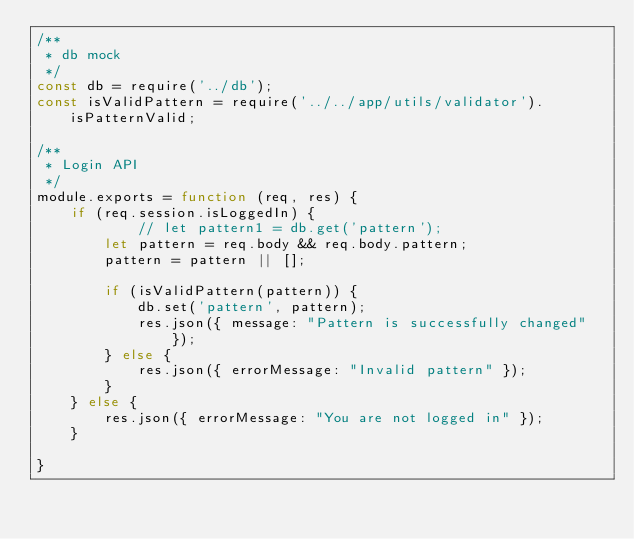Convert code to text. <code><loc_0><loc_0><loc_500><loc_500><_JavaScript_>/**
 * db mock
 */
const db = require('../db');
const isValidPattern = require('../../app/utils/validator').isPatternValid;

/**
 * Login API
 */
module.exports = function (req, res) {
	if (req.session.isLoggedIn) {
			// let pattern1 = db.get('pattern');
		let pattern = req.body && req.body.pattern;
		pattern = pattern || [];

		if (isValidPattern(pattern)) {
			db.set('pattern', pattern);
	    	res.json({ message: "Pattern is successfully changed" });
		} else {
	    	res.json({ errorMessage: "Invalid pattern" });
		}
	} else {
		res.json({ errorMessage: "You are not logged in" });
	}

}</code> 